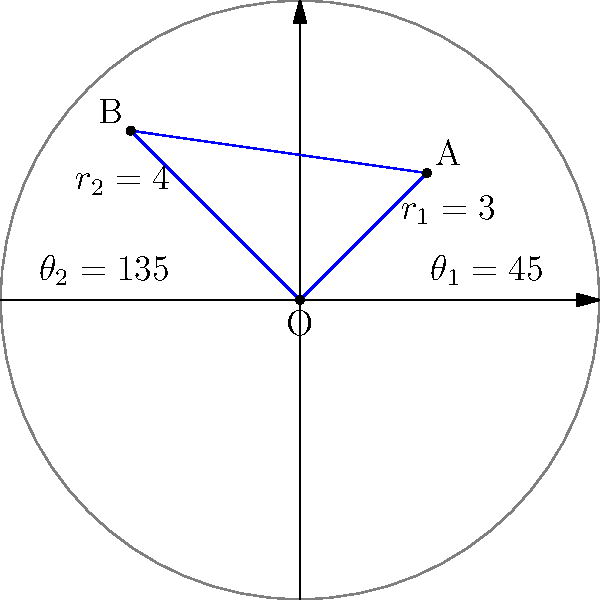Channel 6 is reporting on two new landmarks in St. Clair. The first landmark (A) is located 3 miles from the city center at an angle of 45°, while the second landmark (B) is 4 miles from the center at an angle of 135°. Using polar coordinates, what is the distance between these two landmarks? To find the distance between the two landmarks, we can use the law of cosines for polar coordinates:

1) Let's define our variables:
   $r_1 = 3$ (distance of A from center)
   $r_2 = 4$ (distance of B from center)
   $\theta_1 = 45°$
   $\theta_2 = 135°$

2) The formula for the distance $d$ between two points in polar coordinates is:
   $d^2 = r_1^2 + r_2^2 - 2r_1r_2 \cos(\theta_2 - \theta_1)$

3) Let's calculate $\theta_2 - \theta_1$:
   $135° - 45° = 90°$

4) Now, let's substitute our values into the formula:
   $d^2 = 3^2 + 4^2 - 2(3)(4) \cos(90°)$

5) Simplify:
   $d^2 = 9 + 16 - 24 \cos(90°)$

6) Remember that $\cos(90°) = 0$:
   $d^2 = 9 + 16 - 0 = 25$

7) Take the square root of both sides:
   $d = \sqrt{25} = 5$

Therefore, the distance between the two landmarks is 5 miles.
Answer: 5 miles 